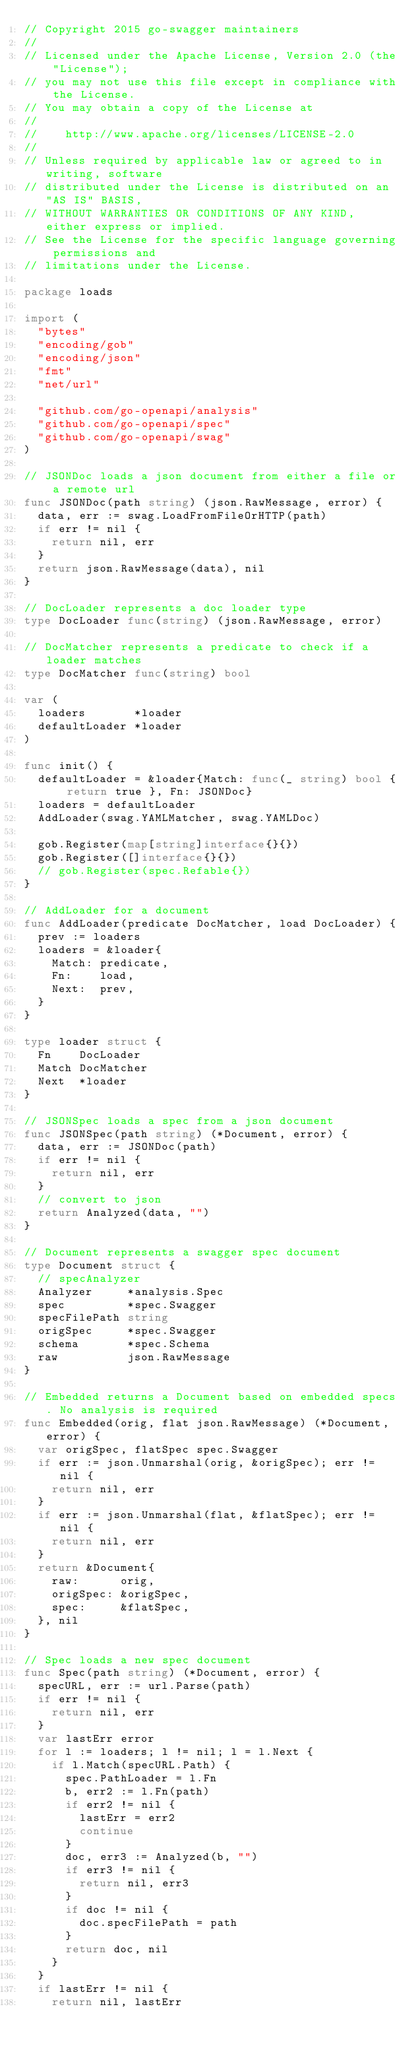Convert code to text. <code><loc_0><loc_0><loc_500><loc_500><_Go_>// Copyright 2015 go-swagger maintainers
//
// Licensed under the Apache License, Version 2.0 (the "License");
// you may not use this file except in compliance with the License.
// You may obtain a copy of the License at
//
//    http://www.apache.org/licenses/LICENSE-2.0
//
// Unless required by applicable law or agreed to in writing, software
// distributed under the License is distributed on an "AS IS" BASIS,
// WITHOUT WARRANTIES OR CONDITIONS OF ANY KIND, either express or implied.
// See the License for the specific language governing permissions and
// limitations under the License.

package loads

import (
	"bytes"
	"encoding/gob"
	"encoding/json"
	"fmt"
	"net/url"

	"github.com/go-openapi/analysis"
	"github.com/go-openapi/spec"
	"github.com/go-openapi/swag"
)

// JSONDoc loads a json document from either a file or a remote url
func JSONDoc(path string) (json.RawMessage, error) {
	data, err := swag.LoadFromFileOrHTTP(path)
	if err != nil {
		return nil, err
	}
	return json.RawMessage(data), nil
}

// DocLoader represents a doc loader type
type DocLoader func(string) (json.RawMessage, error)

// DocMatcher represents a predicate to check if a loader matches
type DocMatcher func(string) bool

var (
	loaders       *loader
	defaultLoader *loader
)

func init() {
	defaultLoader = &loader{Match: func(_ string) bool { return true }, Fn: JSONDoc}
	loaders = defaultLoader
	AddLoader(swag.YAMLMatcher, swag.YAMLDoc)

	gob.Register(map[string]interface{}{})
	gob.Register([]interface{}{})
	// gob.Register(spec.Refable{})
}

// AddLoader for a document
func AddLoader(predicate DocMatcher, load DocLoader) {
	prev := loaders
	loaders = &loader{
		Match: predicate,
		Fn:    load,
		Next:  prev,
	}
}

type loader struct {
	Fn    DocLoader
	Match DocMatcher
	Next  *loader
}

// JSONSpec loads a spec from a json document
func JSONSpec(path string) (*Document, error) {
	data, err := JSONDoc(path)
	if err != nil {
		return nil, err
	}
	// convert to json
	return Analyzed(data, "")
}

// Document represents a swagger spec document
type Document struct {
	// specAnalyzer
	Analyzer     *analysis.Spec
	spec         *spec.Swagger
	specFilePath string
	origSpec     *spec.Swagger
	schema       *spec.Schema
	raw          json.RawMessage
}

// Embedded returns a Document based on embedded specs. No analysis is required
func Embedded(orig, flat json.RawMessage) (*Document, error) {
	var origSpec, flatSpec spec.Swagger
	if err := json.Unmarshal(orig, &origSpec); err != nil {
		return nil, err
	}
	if err := json.Unmarshal(flat, &flatSpec); err != nil {
		return nil, err
	}
	return &Document{
		raw:      orig,
		origSpec: &origSpec,
		spec:     &flatSpec,
	}, nil
}

// Spec loads a new spec document
func Spec(path string) (*Document, error) {
	specURL, err := url.Parse(path)
	if err != nil {
		return nil, err
	}
	var lastErr error
	for l := loaders; l != nil; l = l.Next {
		if l.Match(specURL.Path) {
			spec.PathLoader = l.Fn
			b, err2 := l.Fn(path)
			if err2 != nil {
				lastErr = err2
				continue
			}
			doc, err3 := Analyzed(b, "")
			if err3 != nil {
				return nil, err3
			}
			if doc != nil {
				doc.specFilePath = path
			}
			return doc, nil
		}
	}
	if lastErr != nil {
		return nil, lastErr</code> 